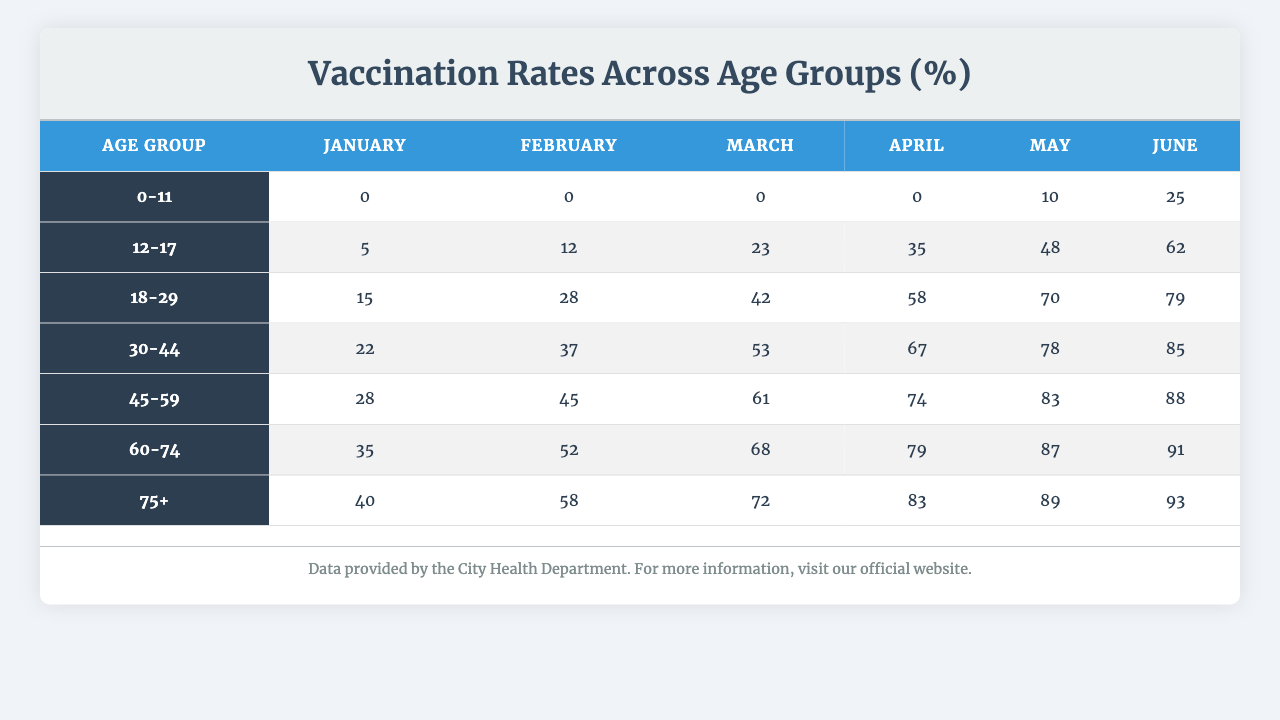What is the vaccination rate for the age group 18-29 in June? The vaccination rate for the age group 18-29 is provided in the June column of the table, which shows 79%.
Answer: 79% Which age group had the highest vaccination rate in April? By comparing the vaccination rates in the April column, the age group 75+ has the highest rate at 83%.
Answer: 75+ What was the increase in vaccination rate for the age group 30-44 from January to May? The vaccination rate for the age group 30-44 in January is 22% and in May is 78%. The difference is calculated as 78% - 22% = 56%.
Answer: 56% Is the vaccination rate for the age group 0-11 ever above 10%? In the table, the vaccination rate for the age group 0-11 is listed as 0% in January, 0% in February, and only increases to 10% in May. Therefore, it is only at 10% in May, but never above.
Answer: No What was the average vaccination rate across all age groups in March? To find the average rate in March, we sum the values for all age groups: 0 + 23 + 42 + 53 + 61 + 68 + 72 = 319. There are 7 age groups, so we divide 319 by 7, which gives approximately 45.57%.
Answer: Approximately 45.57% Which month saw the largest overall increase in vaccination rates across all age groups? To determine this, we need to calculate the total vaccination rate for each month: January is 0 + 5 + 15 + 22 + 28 + 35 + 40 = 145, February is 0 + 12 + 28 + 37 + 45 + 52 + 58 = 232, March is 319, April is 391, May is 408, and June is 429. The largest increase is from April (391) to May (408), which is an increase of 17.
Answer: From April to May What percentage of people in the 60-74 age group were vaccinated by the end of June? The value in the June column for the 60-74 age group is 91%. This is the vaccination rate at the end of June.
Answer: 91% Did any age group reach a vaccination rate above 80% by June? Looking at the June column, the age groups 60-74 and 75+ have rates of 91% and 93%, respectively, both of which are above 80%.
Answer: Yes What is the trend of vaccination rates for the 12-17 age group from January to June? Reviewing the table, the vaccination rates for the 12-17 age group increase from 5% in January to 62% in June, showing an upward trend throughout these months.
Answer: Upward trend Which age group saw the lowest vaccination rate in February? In February, all age groups' vaccination rates are examined, and the age group 0-11 has the lowest rate of 0%.
Answer: 0-11 